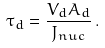Convert formula to latex. <formula><loc_0><loc_0><loc_500><loc_500>\tau _ { d } = \frac { V _ { d } A _ { d } } { J _ { n u c } } \, .</formula> 